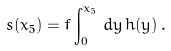<formula> <loc_0><loc_0><loc_500><loc_500>s ( x _ { 5 } ) = f \int _ { 0 } ^ { x _ { 5 } } \, d y \, h ( y ) \, .</formula> 